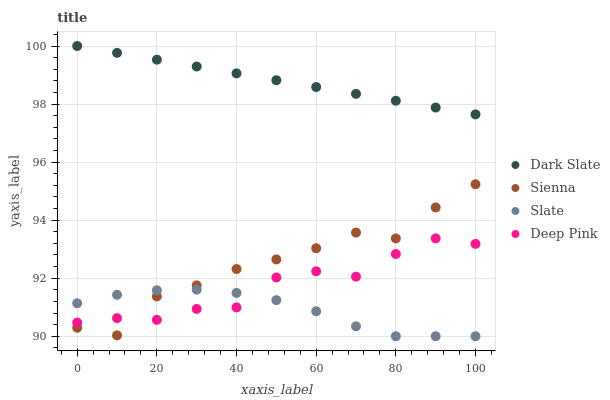Does Slate have the minimum area under the curve?
Answer yes or no. Yes. Does Dark Slate have the maximum area under the curve?
Answer yes or no. Yes. Does Dark Slate have the minimum area under the curve?
Answer yes or no. No. Does Slate have the maximum area under the curve?
Answer yes or no. No. Is Dark Slate the smoothest?
Answer yes or no. Yes. Is Sienna the roughest?
Answer yes or no. Yes. Is Slate the smoothest?
Answer yes or no. No. Is Slate the roughest?
Answer yes or no. No. Does Slate have the lowest value?
Answer yes or no. Yes. Does Dark Slate have the lowest value?
Answer yes or no. No. Does Dark Slate have the highest value?
Answer yes or no. Yes. Does Slate have the highest value?
Answer yes or no. No. Is Deep Pink less than Dark Slate?
Answer yes or no. Yes. Is Dark Slate greater than Deep Pink?
Answer yes or no. Yes. Does Slate intersect Sienna?
Answer yes or no. Yes. Is Slate less than Sienna?
Answer yes or no. No. Is Slate greater than Sienna?
Answer yes or no. No. Does Deep Pink intersect Dark Slate?
Answer yes or no. No. 